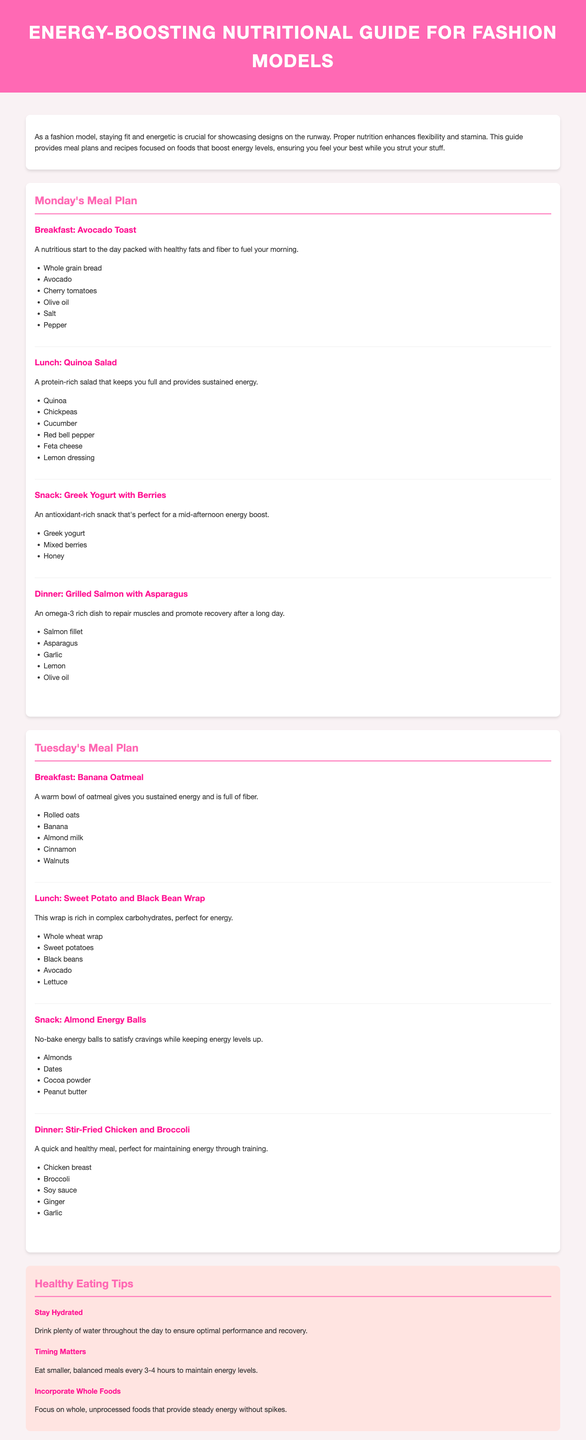What is the title of the document? The title of the document is prominently displayed in the header.
Answer: Energy-Boosting Nutritional Guide for Fashion Models What is the first meal listed for Monday? The first meal in Monday's meal plan is mentioned right after the heading for the meal plan.
Answer: Avocado Toast Which food is included in the lunch for Tuesday? The lunch for Tuesday is provided as a description along with the list of ingredients.
Answer: Sweet Potato and Black Bean Wrap What is one of the tips mentioned in the healthy eating tips section? The healthy eating tips section contains several individual tips listed.
Answer: Stay Hydrated How many meals are there in Monday's meal plan? The number of meals is indicated by the meal sections provided.
Answer: Four Which ingredient is common in the snack for both Monday and Tuesday? The snacks for both days can be analyzed to find repeating ingredients.
Answer: None (Greek yogurt and almond energy balls have different ingredients) What type of milk is used in Tuesday's breakfast? The ingredients for Tuesday's breakfast are listed directly beneath the meal description.
Answer: Almond milk What kind of dressing is used in Monday's lunch? The meal description specifies the dressing used in the lunch dish directly.
Answer: Lemon dressing What color is the header background? The header background color is specified in the style section.
Answer: Pink 